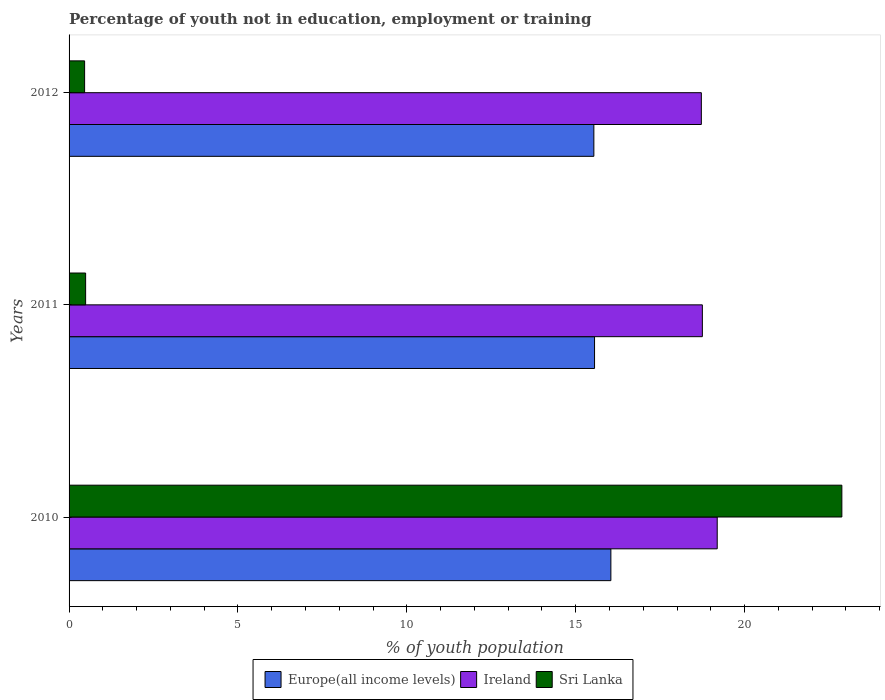How many groups of bars are there?
Your answer should be compact. 3. Are the number of bars per tick equal to the number of legend labels?
Make the answer very short. Yes. How many bars are there on the 3rd tick from the top?
Provide a succinct answer. 3. In how many cases, is the number of bars for a given year not equal to the number of legend labels?
Your answer should be compact. 0. What is the percentage of unemployed youth population in in Ireland in 2012?
Make the answer very short. 18.72. Across all years, what is the maximum percentage of unemployed youth population in in Ireland?
Offer a very short reply. 19.19. Across all years, what is the minimum percentage of unemployed youth population in in Sri Lanka?
Give a very brief answer. 0.46. In which year was the percentage of unemployed youth population in in Europe(all income levels) maximum?
Your response must be concise. 2010. What is the total percentage of unemployed youth population in in Europe(all income levels) in the graph?
Make the answer very short. 47.14. What is the difference between the percentage of unemployed youth population in in Ireland in 2010 and that in 2011?
Keep it short and to the point. 0.44. What is the difference between the percentage of unemployed youth population in in Ireland in 2010 and the percentage of unemployed youth population in in Europe(all income levels) in 2012?
Provide a succinct answer. 3.65. What is the average percentage of unemployed youth population in in Europe(all income levels) per year?
Keep it short and to the point. 15.71. In the year 2010, what is the difference between the percentage of unemployed youth population in in Sri Lanka and percentage of unemployed youth population in in Ireland?
Ensure brevity in your answer.  3.69. In how many years, is the percentage of unemployed youth population in in Sri Lanka greater than 21 %?
Offer a terse response. 1. What is the ratio of the percentage of unemployed youth population in in Sri Lanka in 2010 to that in 2011?
Your response must be concise. 46.69. Is the percentage of unemployed youth population in in Europe(all income levels) in 2010 less than that in 2011?
Provide a short and direct response. No. What is the difference between the highest and the second highest percentage of unemployed youth population in in Europe(all income levels)?
Ensure brevity in your answer.  0.48. What is the difference between the highest and the lowest percentage of unemployed youth population in in Sri Lanka?
Your response must be concise. 22.42. In how many years, is the percentage of unemployed youth population in in Europe(all income levels) greater than the average percentage of unemployed youth population in in Europe(all income levels) taken over all years?
Provide a short and direct response. 1. What does the 1st bar from the top in 2010 represents?
Provide a succinct answer. Sri Lanka. What does the 3rd bar from the bottom in 2012 represents?
Give a very brief answer. Sri Lanka. How many bars are there?
Make the answer very short. 9. Are all the bars in the graph horizontal?
Offer a very short reply. Yes. How many years are there in the graph?
Offer a terse response. 3. Does the graph contain any zero values?
Provide a succinct answer. No. How are the legend labels stacked?
Offer a very short reply. Horizontal. What is the title of the graph?
Your response must be concise. Percentage of youth not in education, employment or training. Does "Myanmar" appear as one of the legend labels in the graph?
Make the answer very short. No. What is the label or title of the X-axis?
Offer a very short reply. % of youth population. What is the % of youth population in Europe(all income levels) in 2010?
Give a very brief answer. 16.04. What is the % of youth population of Ireland in 2010?
Give a very brief answer. 19.19. What is the % of youth population in Sri Lanka in 2010?
Offer a terse response. 22.88. What is the % of youth population in Europe(all income levels) in 2011?
Ensure brevity in your answer.  15.56. What is the % of youth population in Ireland in 2011?
Provide a short and direct response. 18.75. What is the % of youth population in Sri Lanka in 2011?
Provide a succinct answer. 0.49. What is the % of youth population in Europe(all income levels) in 2012?
Your response must be concise. 15.54. What is the % of youth population in Ireland in 2012?
Make the answer very short. 18.72. What is the % of youth population of Sri Lanka in 2012?
Offer a very short reply. 0.46. Across all years, what is the maximum % of youth population in Europe(all income levels)?
Your answer should be very brief. 16.04. Across all years, what is the maximum % of youth population of Ireland?
Your answer should be compact. 19.19. Across all years, what is the maximum % of youth population in Sri Lanka?
Keep it short and to the point. 22.88. Across all years, what is the minimum % of youth population of Europe(all income levels)?
Ensure brevity in your answer.  15.54. Across all years, what is the minimum % of youth population in Ireland?
Provide a succinct answer. 18.72. Across all years, what is the minimum % of youth population in Sri Lanka?
Offer a very short reply. 0.46. What is the total % of youth population of Europe(all income levels) in the graph?
Offer a very short reply. 47.14. What is the total % of youth population in Ireland in the graph?
Your response must be concise. 56.66. What is the total % of youth population of Sri Lanka in the graph?
Your answer should be compact. 23.83. What is the difference between the % of youth population in Europe(all income levels) in 2010 and that in 2011?
Offer a terse response. 0.48. What is the difference between the % of youth population in Ireland in 2010 and that in 2011?
Provide a succinct answer. 0.44. What is the difference between the % of youth population in Sri Lanka in 2010 and that in 2011?
Make the answer very short. 22.39. What is the difference between the % of youth population of Europe(all income levels) in 2010 and that in 2012?
Provide a succinct answer. 0.5. What is the difference between the % of youth population in Ireland in 2010 and that in 2012?
Give a very brief answer. 0.47. What is the difference between the % of youth population of Sri Lanka in 2010 and that in 2012?
Give a very brief answer. 22.42. What is the difference between the % of youth population in Europe(all income levels) in 2011 and that in 2012?
Provide a short and direct response. 0.02. What is the difference between the % of youth population in Ireland in 2011 and that in 2012?
Make the answer very short. 0.03. What is the difference between the % of youth population of Sri Lanka in 2011 and that in 2012?
Make the answer very short. 0.03. What is the difference between the % of youth population of Europe(all income levels) in 2010 and the % of youth population of Ireland in 2011?
Your answer should be very brief. -2.71. What is the difference between the % of youth population of Europe(all income levels) in 2010 and the % of youth population of Sri Lanka in 2011?
Your answer should be very brief. 15.55. What is the difference between the % of youth population of Ireland in 2010 and the % of youth population of Sri Lanka in 2011?
Keep it short and to the point. 18.7. What is the difference between the % of youth population of Europe(all income levels) in 2010 and the % of youth population of Ireland in 2012?
Make the answer very short. -2.68. What is the difference between the % of youth population of Europe(all income levels) in 2010 and the % of youth population of Sri Lanka in 2012?
Offer a terse response. 15.58. What is the difference between the % of youth population in Ireland in 2010 and the % of youth population in Sri Lanka in 2012?
Give a very brief answer. 18.73. What is the difference between the % of youth population of Europe(all income levels) in 2011 and the % of youth population of Ireland in 2012?
Keep it short and to the point. -3.16. What is the difference between the % of youth population of Europe(all income levels) in 2011 and the % of youth population of Sri Lanka in 2012?
Offer a terse response. 15.1. What is the difference between the % of youth population in Ireland in 2011 and the % of youth population in Sri Lanka in 2012?
Make the answer very short. 18.29. What is the average % of youth population in Europe(all income levels) per year?
Offer a terse response. 15.71. What is the average % of youth population of Ireland per year?
Keep it short and to the point. 18.89. What is the average % of youth population in Sri Lanka per year?
Give a very brief answer. 7.94. In the year 2010, what is the difference between the % of youth population of Europe(all income levels) and % of youth population of Ireland?
Provide a short and direct response. -3.15. In the year 2010, what is the difference between the % of youth population of Europe(all income levels) and % of youth population of Sri Lanka?
Your answer should be compact. -6.84. In the year 2010, what is the difference between the % of youth population of Ireland and % of youth population of Sri Lanka?
Offer a terse response. -3.69. In the year 2011, what is the difference between the % of youth population of Europe(all income levels) and % of youth population of Ireland?
Provide a short and direct response. -3.19. In the year 2011, what is the difference between the % of youth population in Europe(all income levels) and % of youth population in Sri Lanka?
Provide a succinct answer. 15.07. In the year 2011, what is the difference between the % of youth population of Ireland and % of youth population of Sri Lanka?
Ensure brevity in your answer.  18.26. In the year 2012, what is the difference between the % of youth population in Europe(all income levels) and % of youth population in Ireland?
Your answer should be very brief. -3.18. In the year 2012, what is the difference between the % of youth population of Europe(all income levels) and % of youth population of Sri Lanka?
Ensure brevity in your answer.  15.08. In the year 2012, what is the difference between the % of youth population of Ireland and % of youth population of Sri Lanka?
Your answer should be very brief. 18.26. What is the ratio of the % of youth population of Europe(all income levels) in 2010 to that in 2011?
Keep it short and to the point. 1.03. What is the ratio of the % of youth population of Ireland in 2010 to that in 2011?
Your response must be concise. 1.02. What is the ratio of the % of youth population of Sri Lanka in 2010 to that in 2011?
Offer a very short reply. 46.69. What is the ratio of the % of youth population in Europe(all income levels) in 2010 to that in 2012?
Ensure brevity in your answer.  1.03. What is the ratio of the % of youth population of Ireland in 2010 to that in 2012?
Provide a short and direct response. 1.03. What is the ratio of the % of youth population of Sri Lanka in 2010 to that in 2012?
Provide a short and direct response. 49.74. What is the ratio of the % of youth population of Ireland in 2011 to that in 2012?
Make the answer very short. 1. What is the ratio of the % of youth population of Sri Lanka in 2011 to that in 2012?
Provide a short and direct response. 1.07. What is the difference between the highest and the second highest % of youth population of Europe(all income levels)?
Your answer should be compact. 0.48. What is the difference between the highest and the second highest % of youth population in Ireland?
Keep it short and to the point. 0.44. What is the difference between the highest and the second highest % of youth population in Sri Lanka?
Ensure brevity in your answer.  22.39. What is the difference between the highest and the lowest % of youth population in Europe(all income levels)?
Your response must be concise. 0.5. What is the difference between the highest and the lowest % of youth population in Ireland?
Keep it short and to the point. 0.47. What is the difference between the highest and the lowest % of youth population of Sri Lanka?
Offer a very short reply. 22.42. 